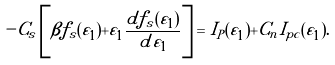<formula> <loc_0><loc_0><loc_500><loc_500>- C _ { s } \left [ \beta f _ { s } ( \tilde { \varepsilon } _ { 1 } ) + \tilde { \varepsilon } _ { 1 } \frac { d f _ { s } ( { \tilde { \varepsilon } _ { 1 } } ) } { d \tilde { \varepsilon } _ { 1 } } \right ] = I _ { P } ( \tilde { \varepsilon } _ { 1 } ) + C _ { n } I _ { p c } ( \tilde { \varepsilon } _ { 1 } ) .</formula> 